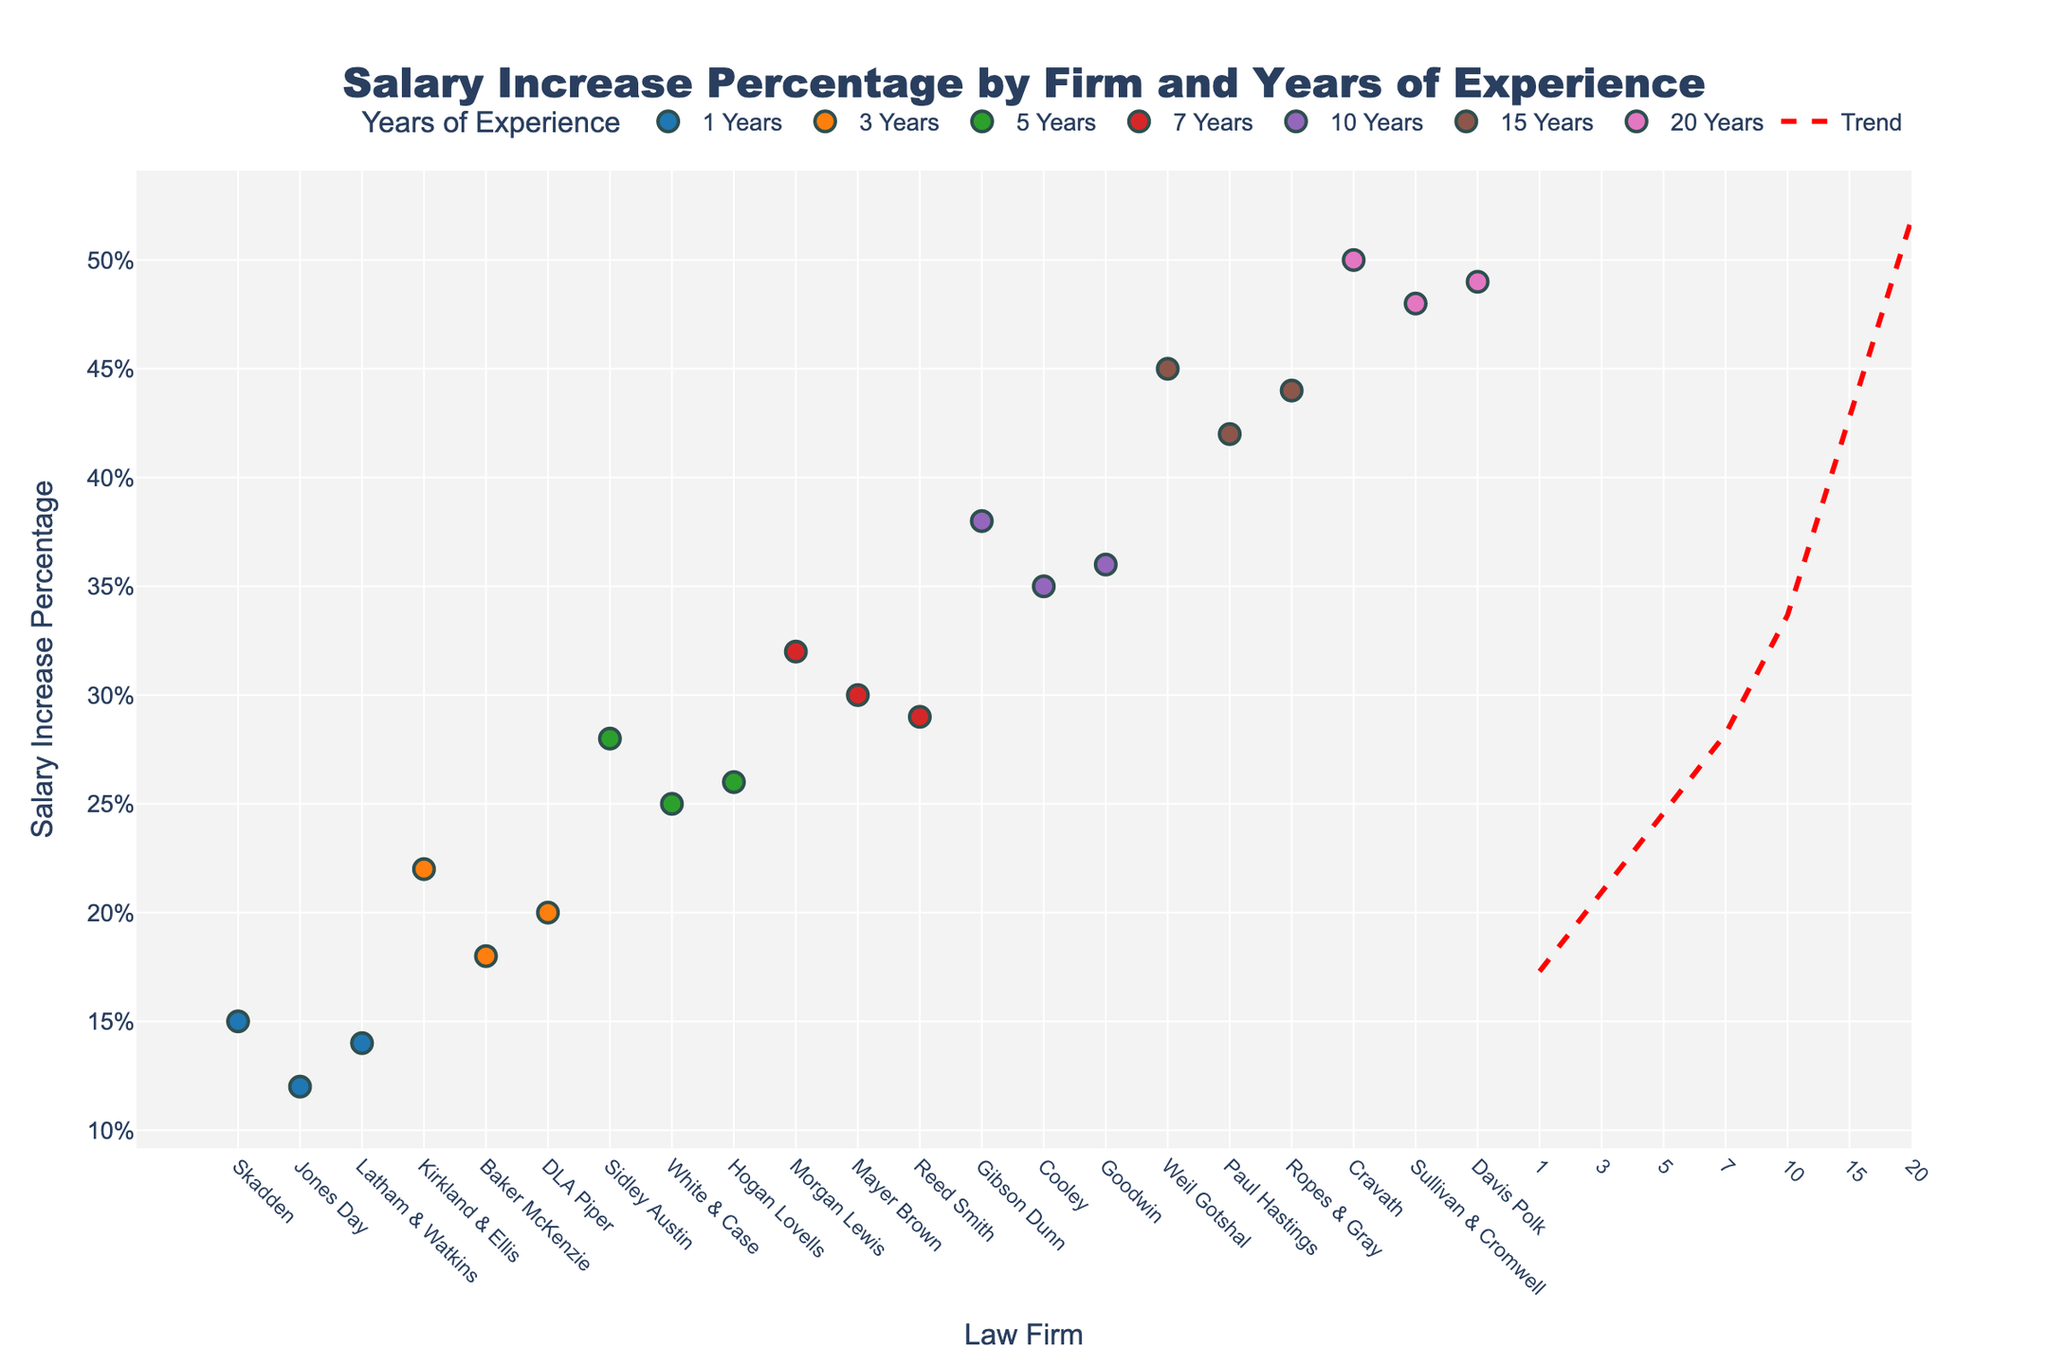What's the title of the plot? The title is displayed at the top of the plot. It represents a concise summary of the entire figure's content.
Answer: Salary Increase Percentage by Firm and Years of Experience What are the x-axis and y-axis titles? The x-axis title is at the bottom of the plot while the y-axis title is on the left. They both specify what each axis represents.
Answer: x-axis: Law Firm, y-axis: Salary Increase Percentage How many firms are represented in the plot? Each data point on the x-axis corresponds to a different law firm. By counting the distinct data points, we determine the number of firms.
Answer: 20 What is the salary increase percentage for someone with 10 years of experience at Gibson Dunn? Look for the marker indicating 10 years of experience and identify the specific firm, then read the corresponding y-axis value.
Answer: 38% Which firm has the highest salary increase percentage? Identify the highest point on the y-axis and trace it back to the corresponding law firm on the x-axis.
Answer: Cravath How do salary increase percentages trend with increasing years of experience overall? Examine the trend line on the plot which is added to show the overall direction of data points. The trend line's slope indicates an overall increase.
Answer: They increase What is the average salary increase percentage for firms representing attorneys with 5 years of experience? Identify all data points labeled as 5 years of experience, sum their salary increase percentages, then divide by the number of those points. (28+25+26) / 3
Answer: 26.33% Which years of experience group has the largest range in salary increase percentages? Compare the range (difference between max and min) in salary increase percentages across each group to find the largest one.
Answer: 20 years (50-48=2) Are there any outliers based on the trend line? If so, identify them. Identify points that are significantly far from the trend line compared to other points. An outlier is determined based on visual deviation from the red trend line.
Answer: No visible significant outliers If an attorney switches to a firm that offers a 45% salary increase, what is their likely years of experience based on the plot? Locate the data point at 45% and identify the years of experience. This point corresponds to the 15 years of experience group.
Answer: 15 years 